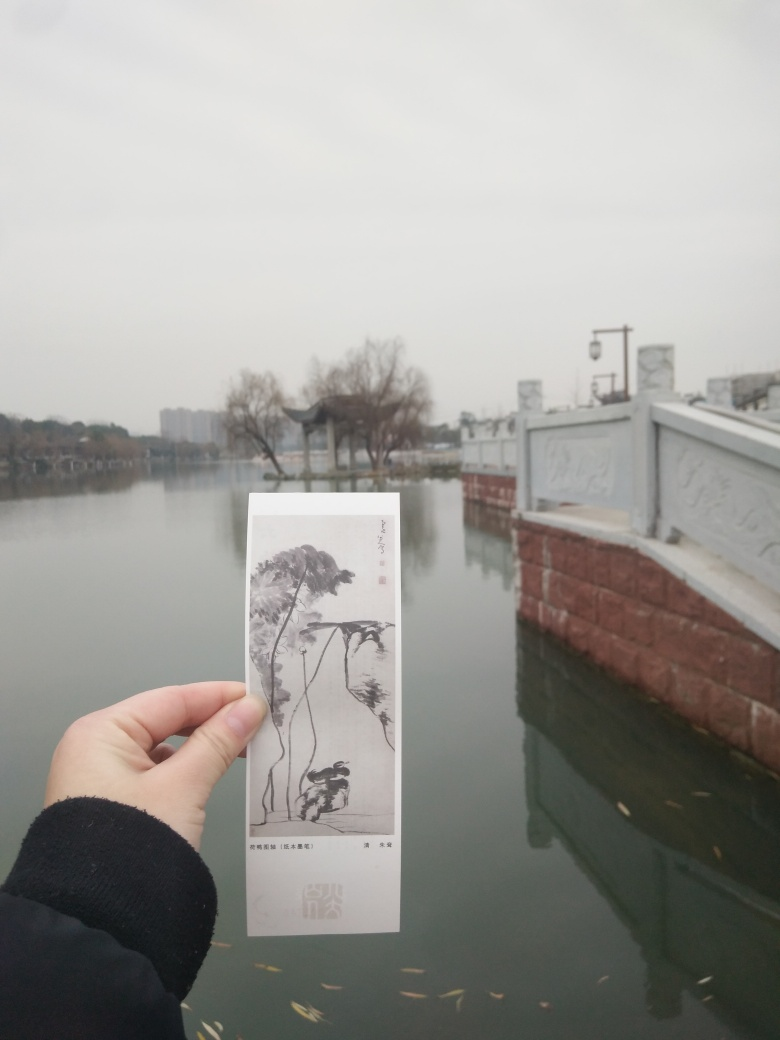How does the bookmark's artwork complement the scene in the background? The artwork on the bookmark depicts a traditional ink painting with plants and a bird, which harmonizes with the serene ambiance of the waterscape. This congruence between the bookmark and the background creates a peaceful and contemplative mood, highlighting a connection between art and nature. 